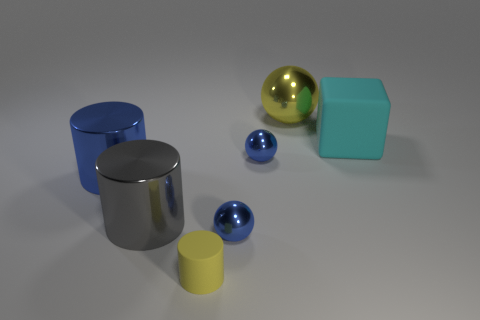Subtract all large cylinders. How many cylinders are left? 1 Add 1 tiny balls. How many objects exist? 8 Subtract all balls. How many objects are left? 4 Add 3 big blue objects. How many big blue objects exist? 4 Subtract 0 green blocks. How many objects are left? 7 Subtract all small objects. Subtract all yellow rubber things. How many objects are left? 3 Add 1 blue cylinders. How many blue cylinders are left? 2 